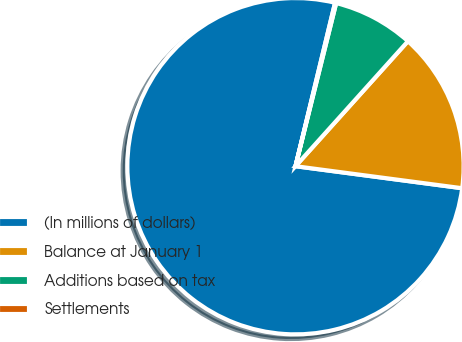<chart> <loc_0><loc_0><loc_500><loc_500><pie_chart><fcel>(In millions of dollars)<fcel>Balance at January 1<fcel>Additions based on tax<fcel>Settlements<nl><fcel>76.69%<fcel>15.43%<fcel>7.77%<fcel>0.11%<nl></chart> 